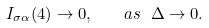<formula> <loc_0><loc_0><loc_500><loc_500>I _ { \sigma \alpha } ( 4 ) \to 0 , \quad a s \ \Delta \to 0 .</formula> 